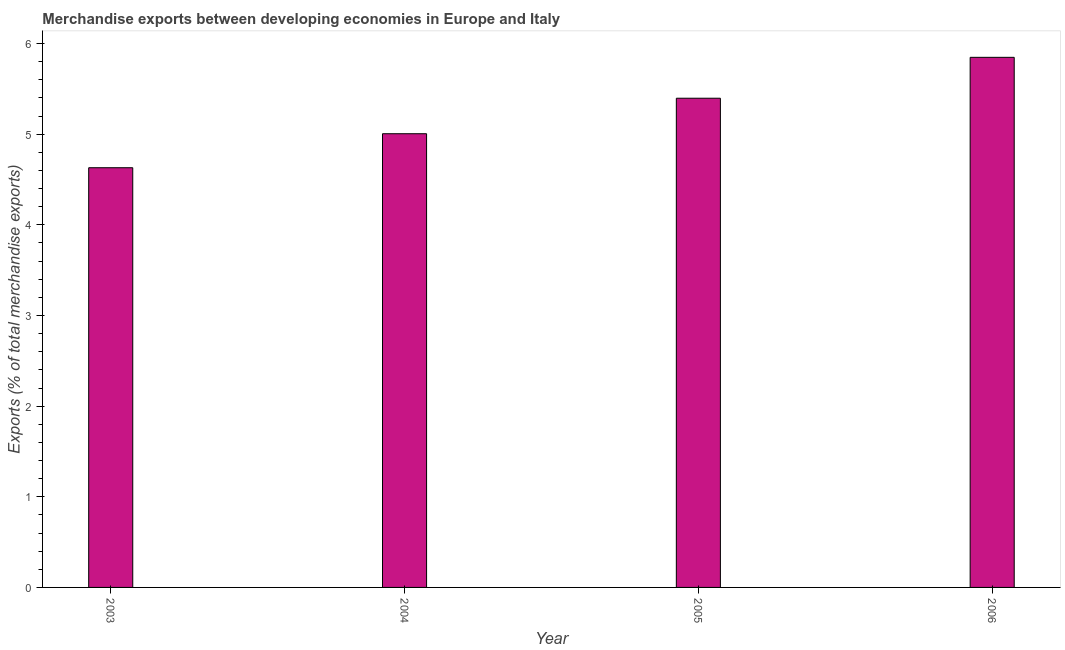Does the graph contain any zero values?
Provide a short and direct response. No. Does the graph contain grids?
Keep it short and to the point. No. What is the title of the graph?
Your answer should be very brief. Merchandise exports between developing economies in Europe and Italy. What is the label or title of the Y-axis?
Your answer should be compact. Exports (% of total merchandise exports). What is the merchandise exports in 2004?
Your response must be concise. 5.01. Across all years, what is the maximum merchandise exports?
Ensure brevity in your answer.  5.85. Across all years, what is the minimum merchandise exports?
Your response must be concise. 4.63. What is the sum of the merchandise exports?
Ensure brevity in your answer.  20.88. What is the difference between the merchandise exports in 2004 and 2005?
Provide a short and direct response. -0.39. What is the average merchandise exports per year?
Offer a very short reply. 5.22. What is the median merchandise exports?
Make the answer very short. 5.2. What is the ratio of the merchandise exports in 2005 to that in 2006?
Offer a very short reply. 0.92. Is the merchandise exports in 2004 less than that in 2005?
Your response must be concise. Yes. What is the difference between the highest and the second highest merchandise exports?
Give a very brief answer. 0.45. What is the difference between the highest and the lowest merchandise exports?
Offer a very short reply. 1.22. How many bars are there?
Your answer should be very brief. 4. How many years are there in the graph?
Your answer should be compact. 4. Are the values on the major ticks of Y-axis written in scientific E-notation?
Provide a succinct answer. No. What is the Exports (% of total merchandise exports) in 2003?
Your response must be concise. 4.63. What is the Exports (% of total merchandise exports) in 2004?
Your response must be concise. 5.01. What is the Exports (% of total merchandise exports) of 2005?
Make the answer very short. 5.4. What is the Exports (% of total merchandise exports) in 2006?
Provide a short and direct response. 5.85. What is the difference between the Exports (% of total merchandise exports) in 2003 and 2004?
Your response must be concise. -0.38. What is the difference between the Exports (% of total merchandise exports) in 2003 and 2005?
Offer a terse response. -0.77. What is the difference between the Exports (% of total merchandise exports) in 2003 and 2006?
Your answer should be very brief. -1.22. What is the difference between the Exports (% of total merchandise exports) in 2004 and 2005?
Your answer should be very brief. -0.39. What is the difference between the Exports (% of total merchandise exports) in 2004 and 2006?
Offer a terse response. -0.84. What is the difference between the Exports (% of total merchandise exports) in 2005 and 2006?
Keep it short and to the point. -0.45. What is the ratio of the Exports (% of total merchandise exports) in 2003 to that in 2004?
Offer a terse response. 0.93. What is the ratio of the Exports (% of total merchandise exports) in 2003 to that in 2005?
Your response must be concise. 0.86. What is the ratio of the Exports (% of total merchandise exports) in 2003 to that in 2006?
Keep it short and to the point. 0.79. What is the ratio of the Exports (% of total merchandise exports) in 2004 to that in 2005?
Provide a short and direct response. 0.93. What is the ratio of the Exports (% of total merchandise exports) in 2004 to that in 2006?
Offer a terse response. 0.86. What is the ratio of the Exports (% of total merchandise exports) in 2005 to that in 2006?
Provide a succinct answer. 0.92. 